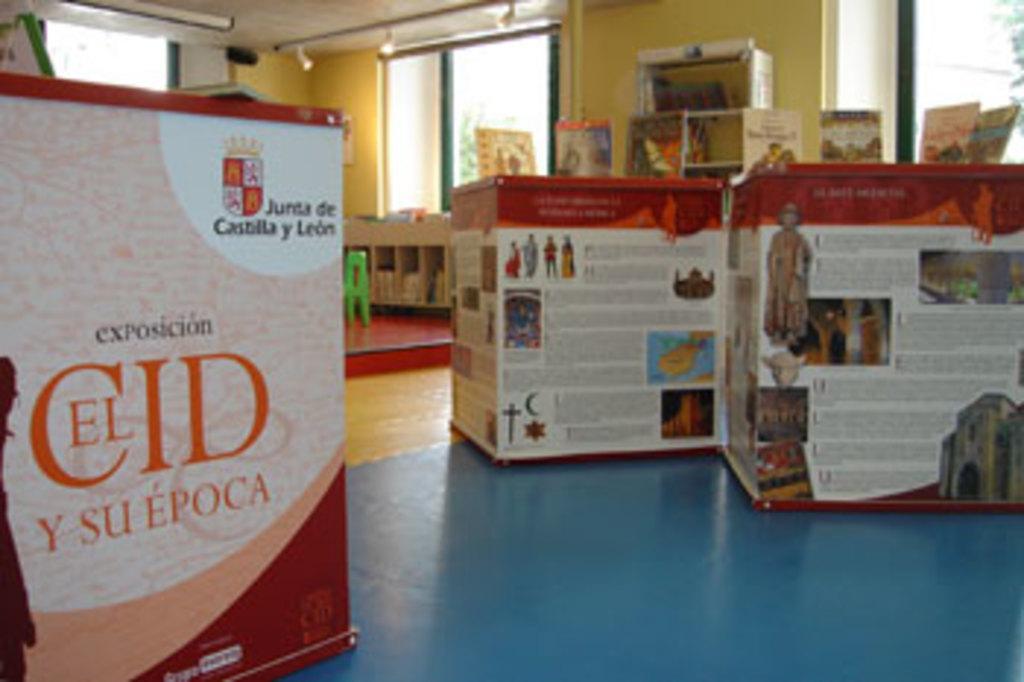In one or two sentences, can you explain what this image depicts? In this picture I can see boxes, boards, windows, lights and some other objects. 